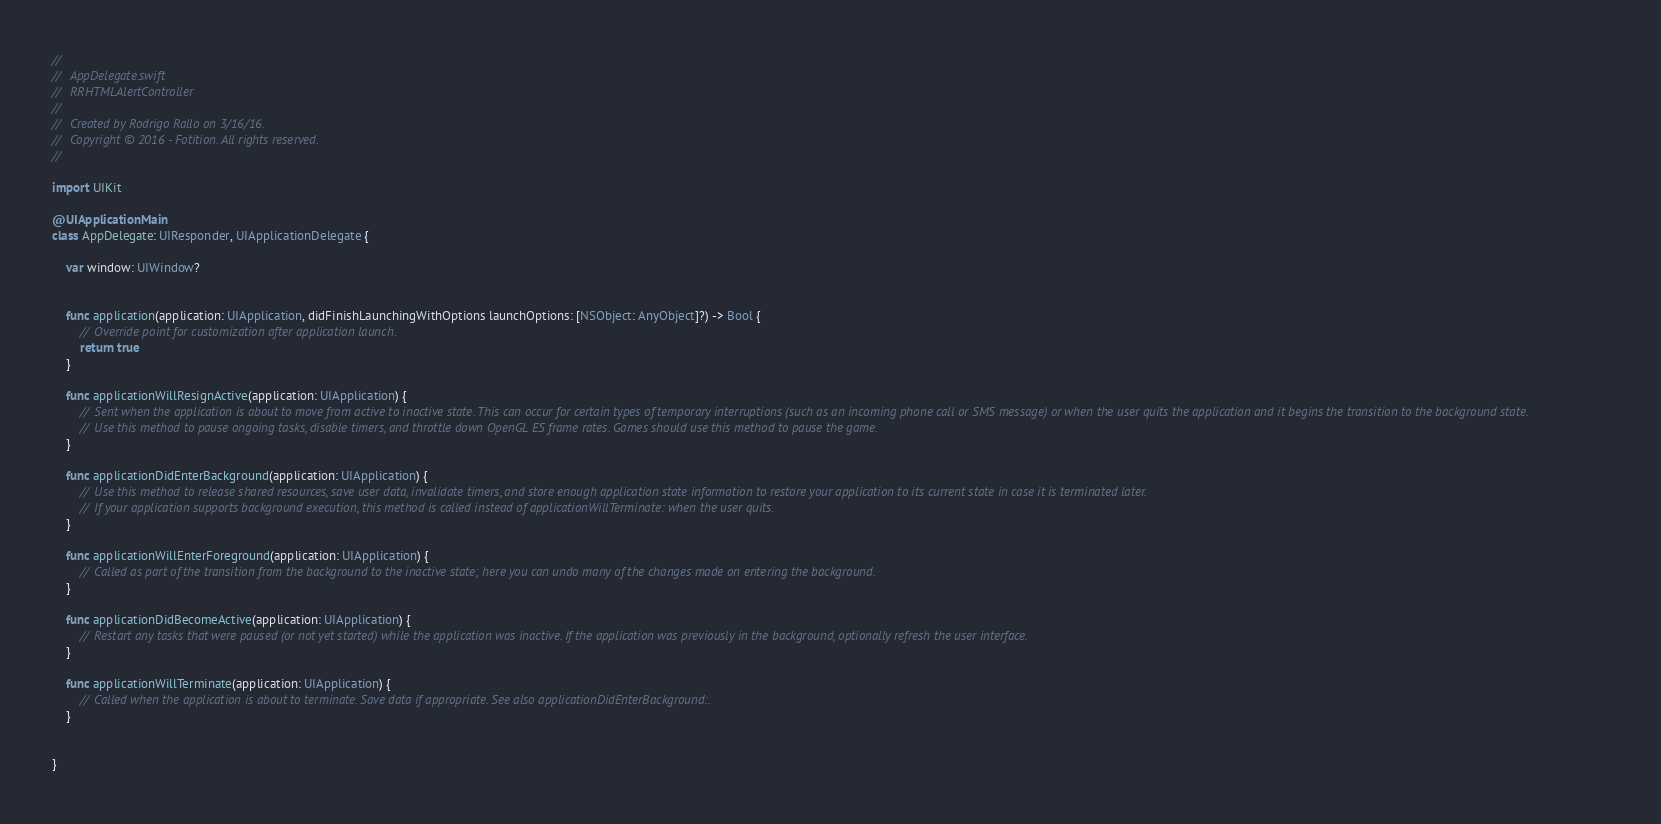<code> <loc_0><loc_0><loc_500><loc_500><_Swift_>//
//  AppDelegate.swift
//  RRHTMLAlertController
//
//  Created by Rodrigo Rallo on 3/16/16.
//  Copyright © 2016 - Fotition. All rights reserved.
//

import UIKit

@UIApplicationMain
class AppDelegate: UIResponder, UIApplicationDelegate {

    var window: UIWindow?


    func application(application: UIApplication, didFinishLaunchingWithOptions launchOptions: [NSObject: AnyObject]?) -> Bool {
        // Override point for customization after application launch.
        return true
    }

    func applicationWillResignActive(application: UIApplication) {
        // Sent when the application is about to move from active to inactive state. This can occur for certain types of temporary interruptions (such as an incoming phone call or SMS message) or when the user quits the application and it begins the transition to the background state.
        // Use this method to pause ongoing tasks, disable timers, and throttle down OpenGL ES frame rates. Games should use this method to pause the game.
    }

    func applicationDidEnterBackground(application: UIApplication) {
        // Use this method to release shared resources, save user data, invalidate timers, and store enough application state information to restore your application to its current state in case it is terminated later.
        // If your application supports background execution, this method is called instead of applicationWillTerminate: when the user quits.
    }

    func applicationWillEnterForeground(application: UIApplication) {
        // Called as part of the transition from the background to the inactive state; here you can undo many of the changes made on entering the background.
    }

    func applicationDidBecomeActive(application: UIApplication) {
        // Restart any tasks that were paused (or not yet started) while the application was inactive. If the application was previously in the background, optionally refresh the user interface.
    }

    func applicationWillTerminate(application: UIApplication) {
        // Called when the application is about to terminate. Save data if appropriate. See also applicationDidEnterBackground:.
    }


}

</code> 